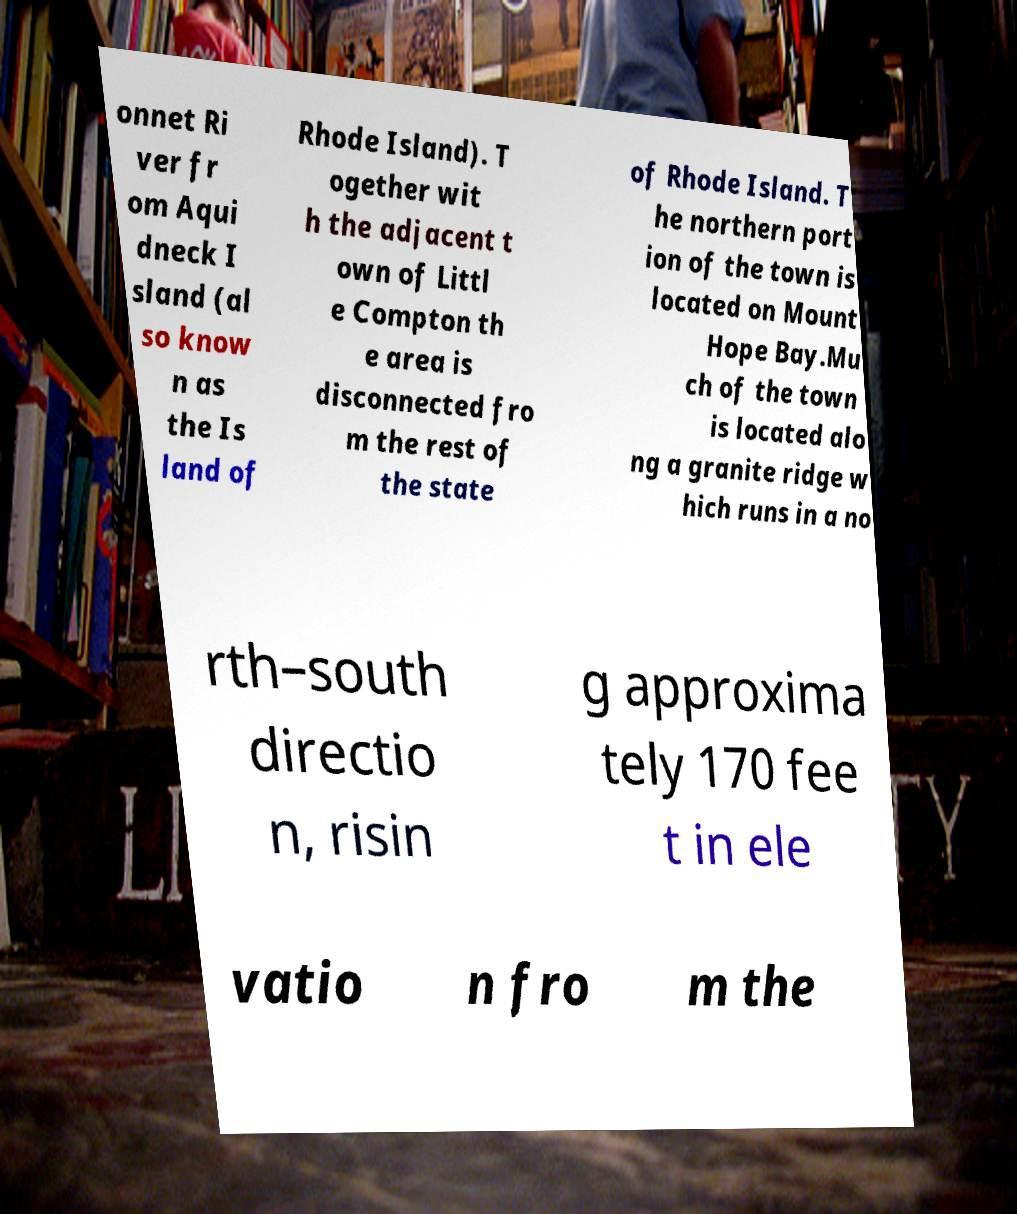For documentation purposes, I need the text within this image transcribed. Could you provide that? onnet Ri ver fr om Aqui dneck I sland (al so know n as the Is land of Rhode Island). T ogether wit h the adjacent t own of Littl e Compton th e area is disconnected fro m the rest of the state of Rhode Island. T he northern port ion of the town is located on Mount Hope Bay.Mu ch of the town is located alo ng a granite ridge w hich runs in a no rth–south directio n, risin g approxima tely 170 fee t in ele vatio n fro m the 